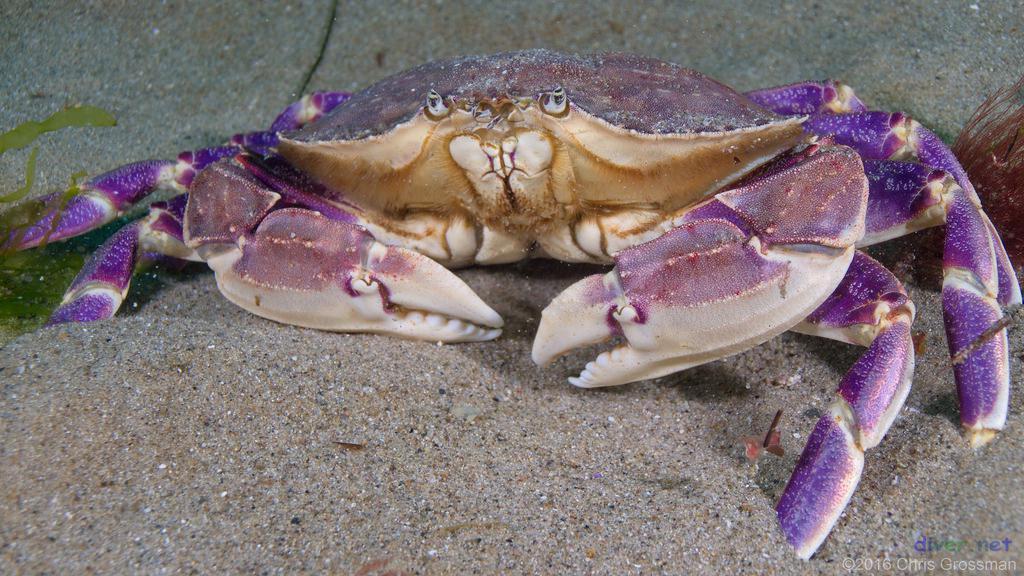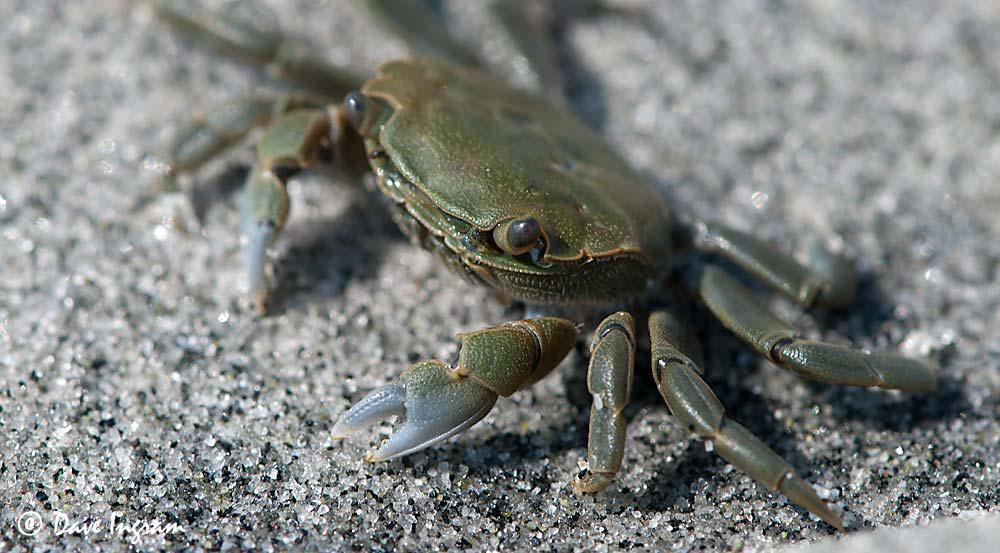The first image is the image on the left, the second image is the image on the right. Evaluate the accuracy of this statement regarding the images: "In at least one image there is a hand touching a crab.". Is it true? Answer yes or no. No. The first image is the image on the left, the second image is the image on the right. Examine the images to the left and right. Is the description "The left image contains a human touching a crab." accurate? Answer yes or no. No. 